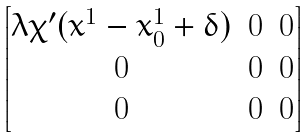Convert formula to latex. <formula><loc_0><loc_0><loc_500><loc_500>\begin{bmatrix} \lambda \chi ^ { \prime } ( x ^ { 1 } - x _ { 0 } ^ { 1 } + \delta ) & 0 & 0 \\ 0 & 0 & 0 \\ 0 & 0 & 0 \end{bmatrix}</formula> 